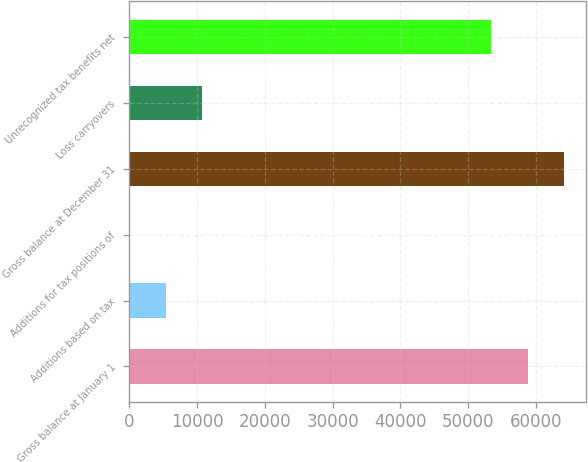Convert chart to OTSL. <chart><loc_0><loc_0><loc_500><loc_500><bar_chart><fcel>Gross balance at January 1<fcel>Additions based on tax<fcel>Additions for tax positions of<fcel>Gross balance at December 31<fcel>Loss carryovers<fcel>Unrecognized tax benefits net<nl><fcel>58775.9<fcel>5432.9<fcel>48<fcel>64160.8<fcel>10817.8<fcel>53391<nl></chart> 